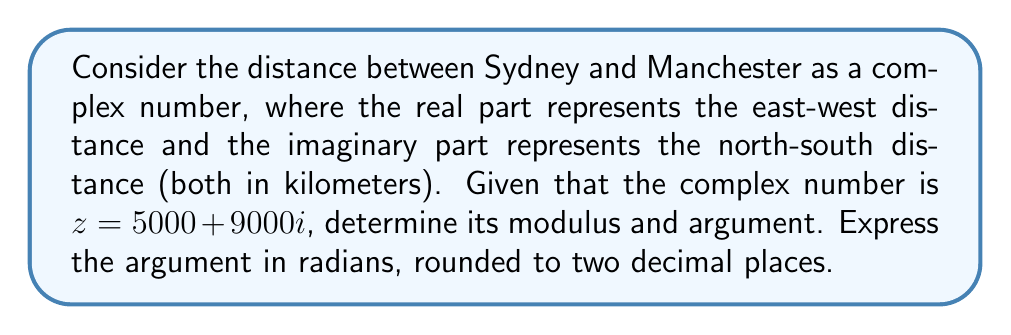Can you answer this question? To find the modulus and argument of the complex number $z = 5000 + 9000i$, we'll follow these steps:

1. Calculate the modulus:
   The modulus of a complex number $z = a + bi$ is given by $|z| = \sqrt{a^2 + b^2}$
   $$|z| = \sqrt{5000^2 + 9000^2} = \sqrt{25,000,000 + 81,000,000} = \sqrt{106,000,000} \approx 10,295.63$$

2. Calculate the argument:
   The argument of a complex number is given by $\arg(z) = \tan^{-1}(\frac{b}{a})$
   $$\arg(z) = \tan^{-1}(\frac{9000}{5000}) = \tan^{-1}(1.8)$$

   Using a calculator or computer, we get:
   $$\arg(z) \approx 1.0637 \text{ radians}$$

   Rounding to two decimal places:
   $$\arg(z) \approx 1.06 \text{ radians}$$

The modulus represents the straight-line distance between Sydney and Manchester, while the argument represents the angle from the positive real axis (east) to the line connecting the two cities.
Answer: Modulus: $10,295.63$ km, Argument: $1.06$ radians 